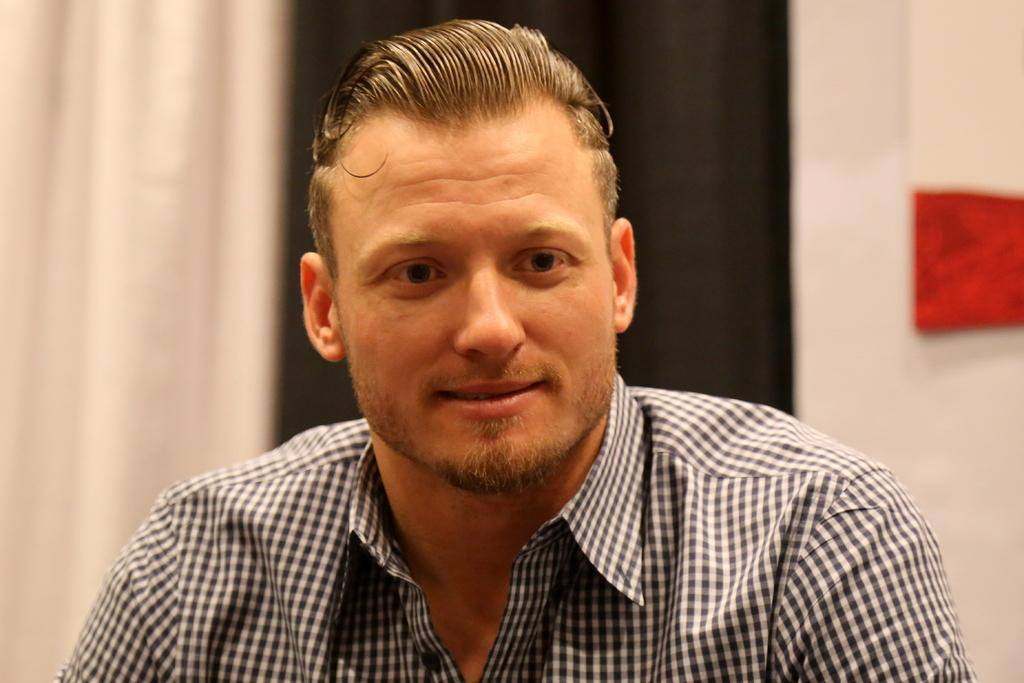Who is present in the image? There is a man in the image. What is the man doing in the image? The man is sitting. What type of throne does the ghost sit on in the image? There is no ghost or throne present in the image; it only features a man sitting. 